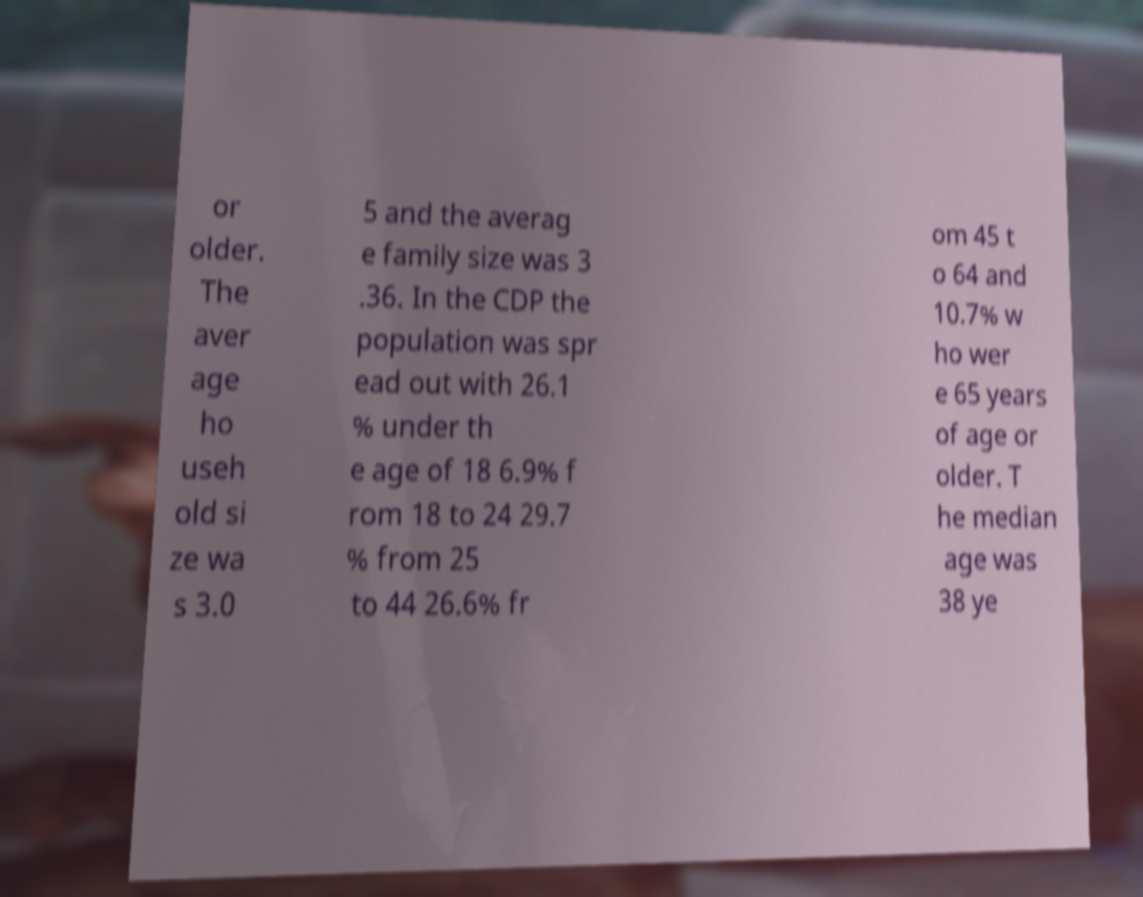There's text embedded in this image that I need extracted. Can you transcribe it verbatim? or older. The aver age ho useh old si ze wa s 3.0 5 and the averag e family size was 3 .36. In the CDP the population was spr ead out with 26.1 % under th e age of 18 6.9% f rom 18 to 24 29.7 % from 25 to 44 26.6% fr om 45 t o 64 and 10.7% w ho wer e 65 years of age or older. T he median age was 38 ye 